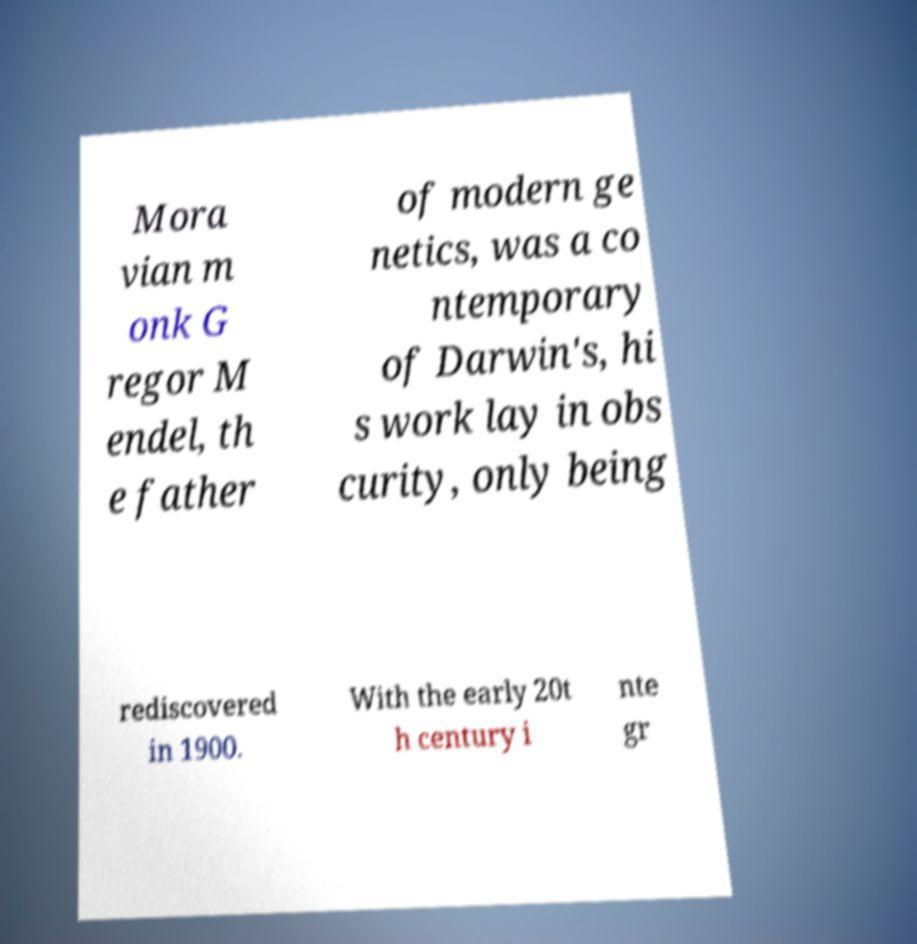Can you accurately transcribe the text from the provided image for me? Mora vian m onk G regor M endel, th e father of modern ge netics, was a co ntemporary of Darwin's, hi s work lay in obs curity, only being rediscovered in 1900. With the early 20t h century i nte gr 